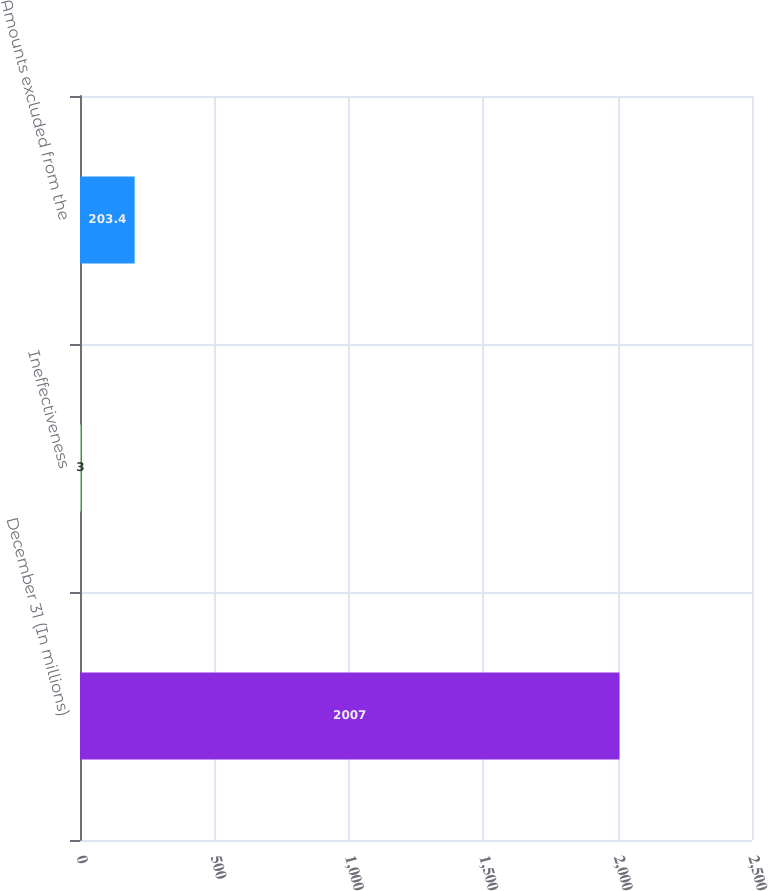Convert chart to OTSL. <chart><loc_0><loc_0><loc_500><loc_500><bar_chart><fcel>December 31 (In millions)<fcel>Ineffectiveness<fcel>Amounts excluded from the<nl><fcel>2007<fcel>3<fcel>203.4<nl></chart> 